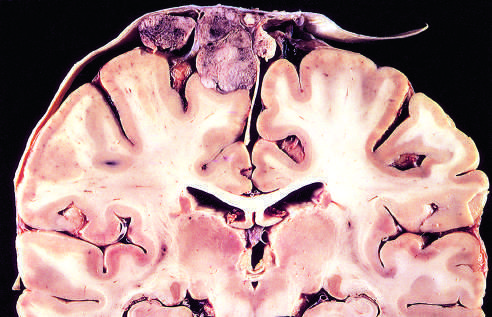s parasagittal multilobular meningioma attached to the dura with compression of underlying brain?
Answer the question using a single word or phrase. Yes 